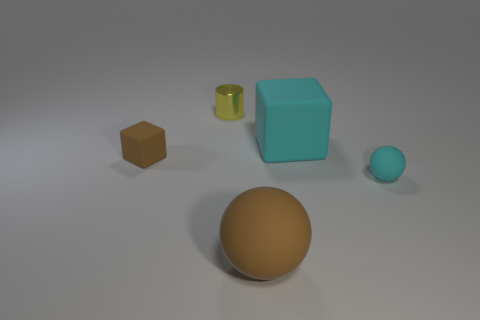Does the small matte thing to the left of the tiny shiny thing have the same shape as the large matte object that is on the right side of the big matte ball?
Your answer should be compact. Yes. There is a tiny matte object on the right side of the cyan thing that is behind the cube that is to the left of the yellow cylinder; what is its color?
Offer a terse response. Cyan. How many other objects are the same color as the tiny cylinder?
Keep it short and to the point. 0. Are there fewer large objects than large matte blocks?
Your answer should be very brief. No. What color is the matte object that is both in front of the brown block and on the left side of the small cyan rubber object?
Give a very brief answer. Brown. What material is the tiny cyan object that is the same shape as the big brown matte object?
Keep it short and to the point. Rubber. Are there any other things that have the same size as the yellow metal cylinder?
Ensure brevity in your answer.  Yes. Is the number of tiny rubber objects greater than the number of cyan spheres?
Ensure brevity in your answer.  Yes. There is a matte thing that is both on the right side of the brown matte ball and on the left side of the tiny ball; what is its size?
Your answer should be very brief. Large. What shape is the large cyan rubber thing?
Keep it short and to the point. Cube. 